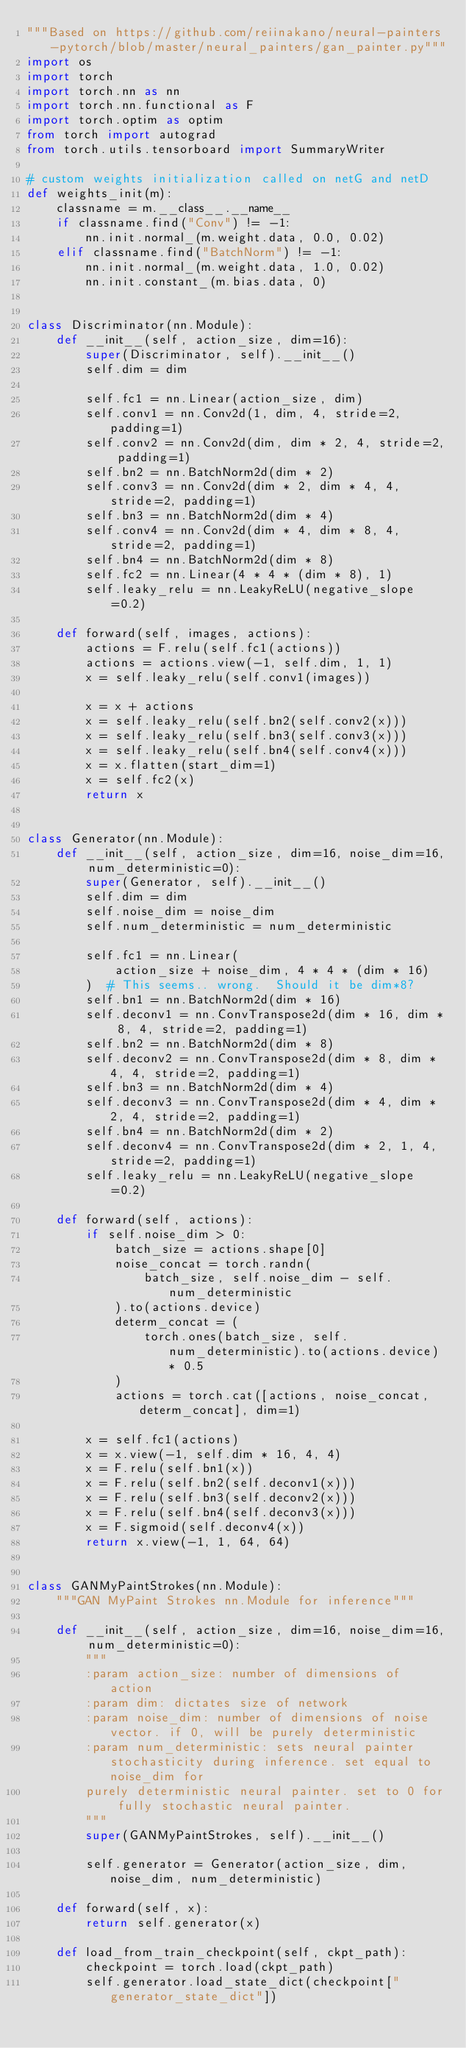<code> <loc_0><loc_0><loc_500><loc_500><_Python_>"""Based on https://github.com/reiinakano/neural-painters-pytorch/blob/master/neural_painters/gan_painter.py"""
import os
import torch
import torch.nn as nn
import torch.nn.functional as F
import torch.optim as optim
from torch import autograd
from torch.utils.tensorboard import SummaryWriter

# custom weights initialization called on netG and netD
def weights_init(m):
    classname = m.__class__.__name__
    if classname.find("Conv") != -1:
        nn.init.normal_(m.weight.data, 0.0, 0.02)
    elif classname.find("BatchNorm") != -1:
        nn.init.normal_(m.weight.data, 1.0, 0.02)
        nn.init.constant_(m.bias.data, 0)


class Discriminator(nn.Module):
    def __init__(self, action_size, dim=16):
        super(Discriminator, self).__init__()
        self.dim = dim

        self.fc1 = nn.Linear(action_size, dim)
        self.conv1 = nn.Conv2d(1, dim, 4, stride=2, padding=1)
        self.conv2 = nn.Conv2d(dim, dim * 2, 4, stride=2, padding=1)
        self.bn2 = nn.BatchNorm2d(dim * 2)
        self.conv3 = nn.Conv2d(dim * 2, dim * 4, 4, stride=2, padding=1)
        self.bn3 = nn.BatchNorm2d(dim * 4)
        self.conv4 = nn.Conv2d(dim * 4, dim * 8, 4, stride=2, padding=1)
        self.bn4 = nn.BatchNorm2d(dim * 8)
        self.fc2 = nn.Linear(4 * 4 * (dim * 8), 1)
        self.leaky_relu = nn.LeakyReLU(negative_slope=0.2)

    def forward(self, images, actions):
        actions = F.relu(self.fc1(actions))
        actions = actions.view(-1, self.dim, 1, 1)
        x = self.leaky_relu(self.conv1(images))

        x = x + actions
        x = self.leaky_relu(self.bn2(self.conv2(x)))
        x = self.leaky_relu(self.bn3(self.conv3(x)))
        x = self.leaky_relu(self.bn4(self.conv4(x)))
        x = x.flatten(start_dim=1)
        x = self.fc2(x)
        return x


class Generator(nn.Module):
    def __init__(self, action_size, dim=16, noise_dim=16, num_deterministic=0):
        super(Generator, self).__init__()
        self.dim = dim
        self.noise_dim = noise_dim
        self.num_deterministic = num_deterministic

        self.fc1 = nn.Linear(
            action_size + noise_dim, 4 * 4 * (dim * 16)
        )  # This seems.. wrong.  Should it be dim*8?
        self.bn1 = nn.BatchNorm2d(dim * 16)
        self.deconv1 = nn.ConvTranspose2d(dim * 16, dim * 8, 4, stride=2, padding=1)
        self.bn2 = nn.BatchNorm2d(dim * 8)
        self.deconv2 = nn.ConvTranspose2d(dim * 8, dim * 4, 4, stride=2, padding=1)
        self.bn3 = nn.BatchNorm2d(dim * 4)
        self.deconv3 = nn.ConvTranspose2d(dim * 4, dim * 2, 4, stride=2, padding=1)
        self.bn4 = nn.BatchNorm2d(dim * 2)
        self.deconv4 = nn.ConvTranspose2d(dim * 2, 1, 4, stride=2, padding=1)
        self.leaky_relu = nn.LeakyReLU(negative_slope=0.2)

    def forward(self, actions):
        if self.noise_dim > 0:
            batch_size = actions.shape[0]
            noise_concat = torch.randn(
                batch_size, self.noise_dim - self.num_deterministic
            ).to(actions.device)
            determ_concat = (
                torch.ones(batch_size, self.num_deterministic).to(actions.device) * 0.5
            )
            actions = torch.cat([actions, noise_concat, determ_concat], dim=1)

        x = self.fc1(actions)
        x = x.view(-1, self.dim * 16, 4, 4)
        x = F.relu(self.bn1(x))
        x = F.relu(self.bn2(self.deconv1(x)))
        x = F.relu(self.bn3(self.deconv2(x)))
        x = F.relu(self.bn4(self.deconv3(x)))
        x = F.sigmoid(self.deconv4(x))
        return x.view(-1, 1, 64, 64)


class GANMyPaintStrokes(nn.Module):
    """GAN MyPaint Strokes nn.Module for inference"""

    def __init__(self, action_size, dim=16, noise_dim=16, num_deterministic=0):
        """
        :param action_size: number of dimensions of action
        :param dim: dictates size of network
        :param noise_dim: number of dimensions of noise vector. if 0, will be purely deterministic
        :param num_deterministic: sets neural painter stochasticity during inference. set equal to noise_dim for
        purely deterministic neural painter. set to 0 for fully stochastic neural painter.
        """
        super(GANMyPaintStrokes, self).__init__()

        self.generator = Generator(action_size, dim, noise_dim, num_deterministic)

    def forward(self, x):
        return self.generator(x)

    def load_from_train_checkpoint(self, ckpt_path):
        checkpoint = torch.load(ckpt_path)
        self.generator.load_state_dict(checkpoint["generator_state_dict"])</code> 